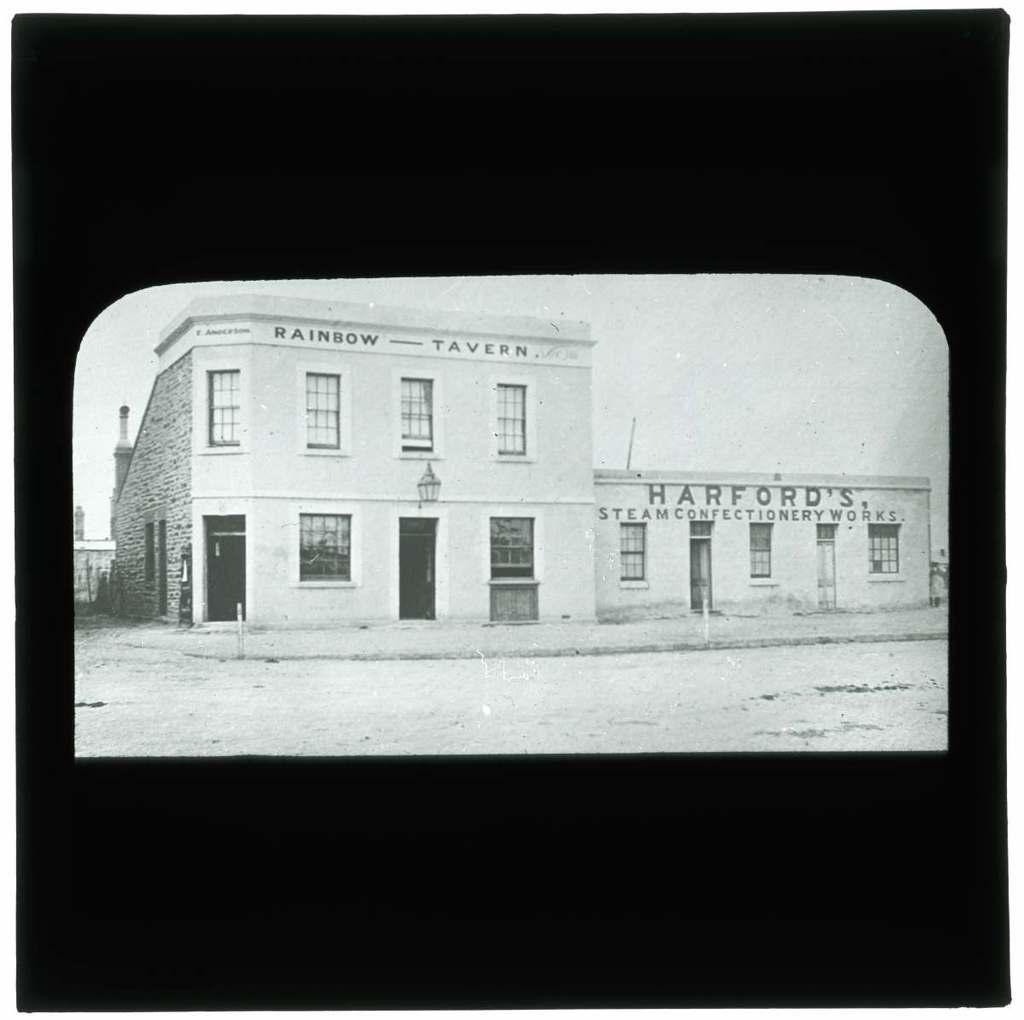What type of structures can be seen in the image? There are buildings in the image. What architectural features are present on the buildings? There are windows and doors visible on the buildings. What type of lighting is present in the image? There is a street lamp in the image. What type of structure is present on the roof of one of the buildings? There is a chimney in the image. What type of vegetation is present in the image? There are plants in the image. What parts of the natural environment are visible in the image? The sky and the ground are visible in the image. Can you tell me how many pens are visible in the image? There are no pens present in the image. What type of advice does the dad give in the image? There is no dad present in the image, and therefore no advice can be given. 